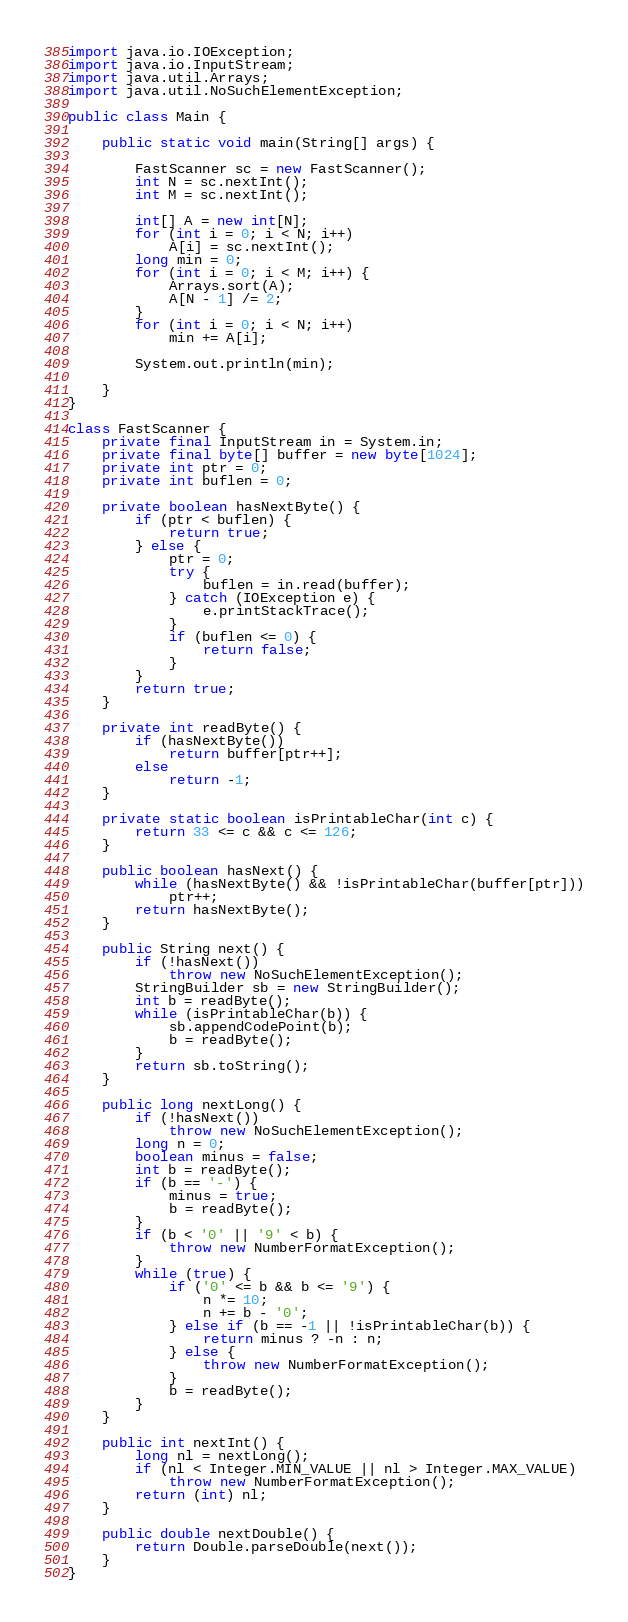<code> <loc_0><loc_0><loc_500><loc_500><_Java_>import java.io.IOException;
import java.io.InputStream;
import java.util.Arrays;
import java.util.NoSuchElementException;

public class Main {

	public static void main(String[] args) {

		FastScanner sc = new FastScanner();
		int N = sc.nextInt();
		int M = sc.nextInt();

		int[] A = new int[N];
		for (int i = 0; i < N; i++)
			A[i] = sc.nextInt();
		long min = 0;
		for (int i = 0; i < M; i++) {
			Arrays.sort(A);
			A[N - 1] /= 2;
		}
		for (int i = 0; i < N; i++)
			min += A[i];

		System.out.println(min);

	}
}

class FastScanner {
	private final InputStream in = System.in;
	private final byte[] buffer = new byte[1024];
	private int ptr = 0;
	private int buflen = 0;

	private boolean hasNextByte() {
		if (ptr < buflen) {
			return true;
		} else {
			ptr = 0;
			try {
				buflen = in.read(buffer);
			} catch (IOException e) {
				e.printStackTrace();
			}
			if (buflen <= 0) {
				return false;
			}
		}
		return true;
	}

	private int readByte() {
		if (hasNextByte())
			return buffer[ptr++];
		else
			return -1;
	}

	private static boolean isPrintableChar(int c) {
		return 33 <= c && c <= 126;
	}

	public boolean hasNext() {
		while (hasNextByte() && !isPrintableChar(buffer[ptr]))
			ptr++;
		return hasNextByte();
	}

	public String next() {
		if (!hasNext())
			throw new NoSuchElementException();
		StringBuilder sb = new StringBuilder();
		int b = readByte();
		while (isPrintableChar(b)) {
			sb.appendCodePoint(b);
			b = readByte();
		}
		return sb.toString();
	}

	public long nextLong() {
		if (!hasNext())
			throw new NoSuchElementException();
		long n = 0;
		boolean minus = false;
		int b = readByte();
		if (b == '-') {
			minus = true;
			b = readByte();
		}
		if (b < '0' || '9' < b) {
			throw new NumberFormatException();
		}
		while (true) {
			if ('0' <= b && b <= '9') {
				n *= 10;
				n += b - '0';
			} else if (b == -1 || !isPrintableChar(b)) {
				return minus ? -n : n;
			} else {
				throw new NumberFormatException();
			}
			b = readByte();
		}
	}

	public int nextInt() {
		long nl = nextLong();
		if (nl < Integer.MIN_VALUE || nl > Integer.MAX_VALUE)
			throw new NumberFormatException();
		return (int) nl;
	}

	public double nextDouble() {
		return Double.parseDouble(next());
	}
}
</code> 